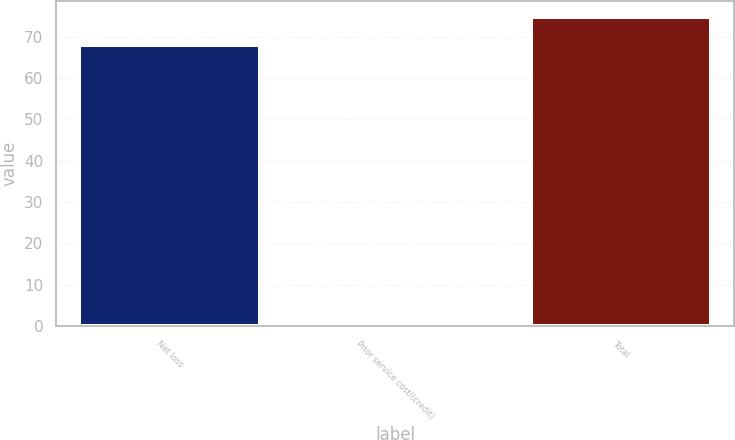Convert chart. <chart><loc_0><loc_0><loc_500><loc_500><bar_chart><fcel>Net loss<fcel>Prior service cost/(credit)<fcel>Total<nl><fcel>68<fcel>1<fcel>74.8<nl></chart> 